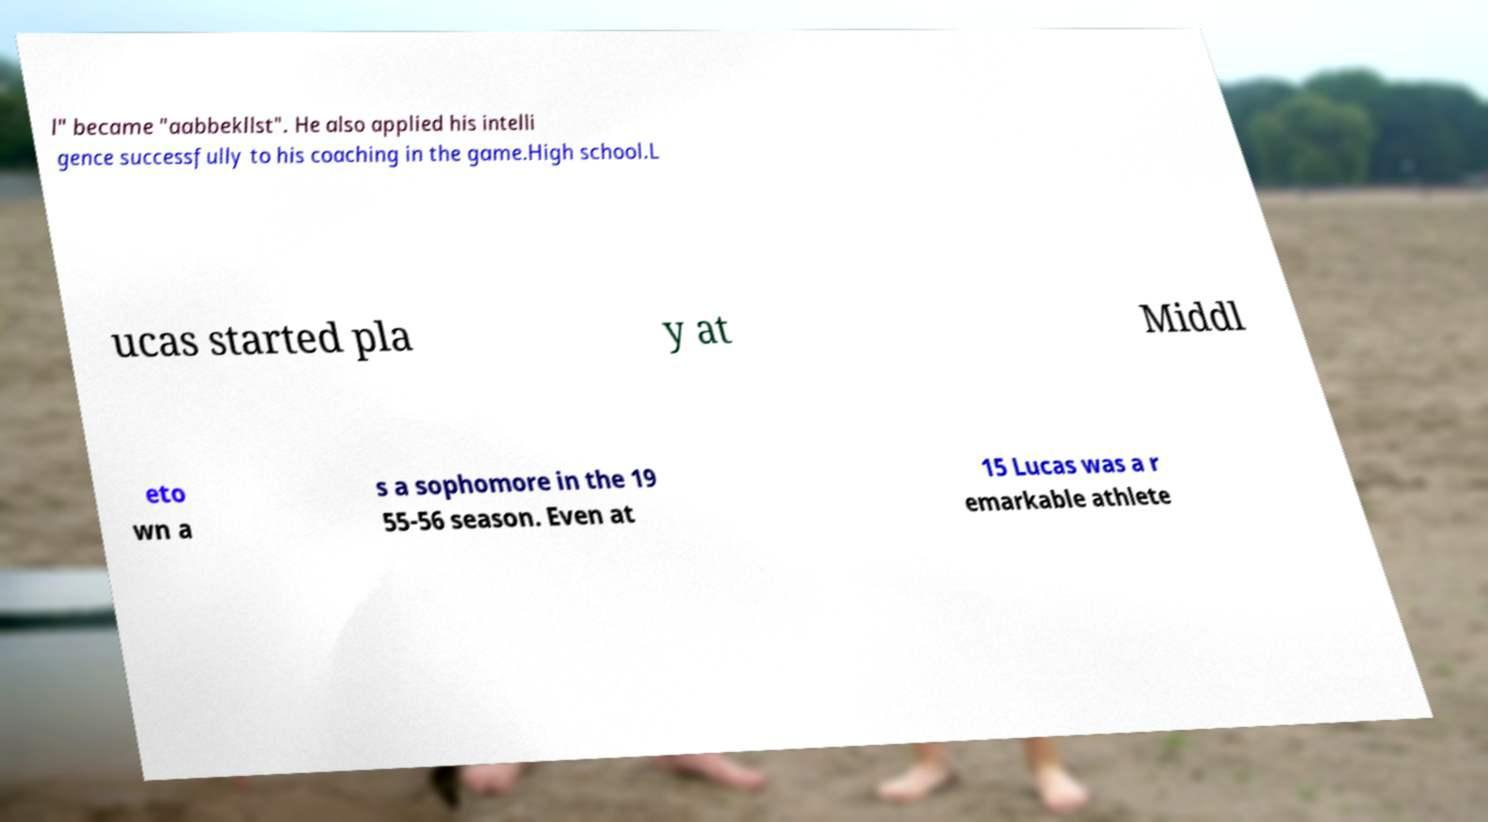Could you assist in decoding the text presented in this image and type it out clearly? l" became "aabbekllst". He also applied his intelli gence successfully to his coaching in the game.High school.L ucas started pla y at Middl eto wn a s a sophomore in the 19 55-56 season. Even at 15 Lucas was a r emarkable athlete 